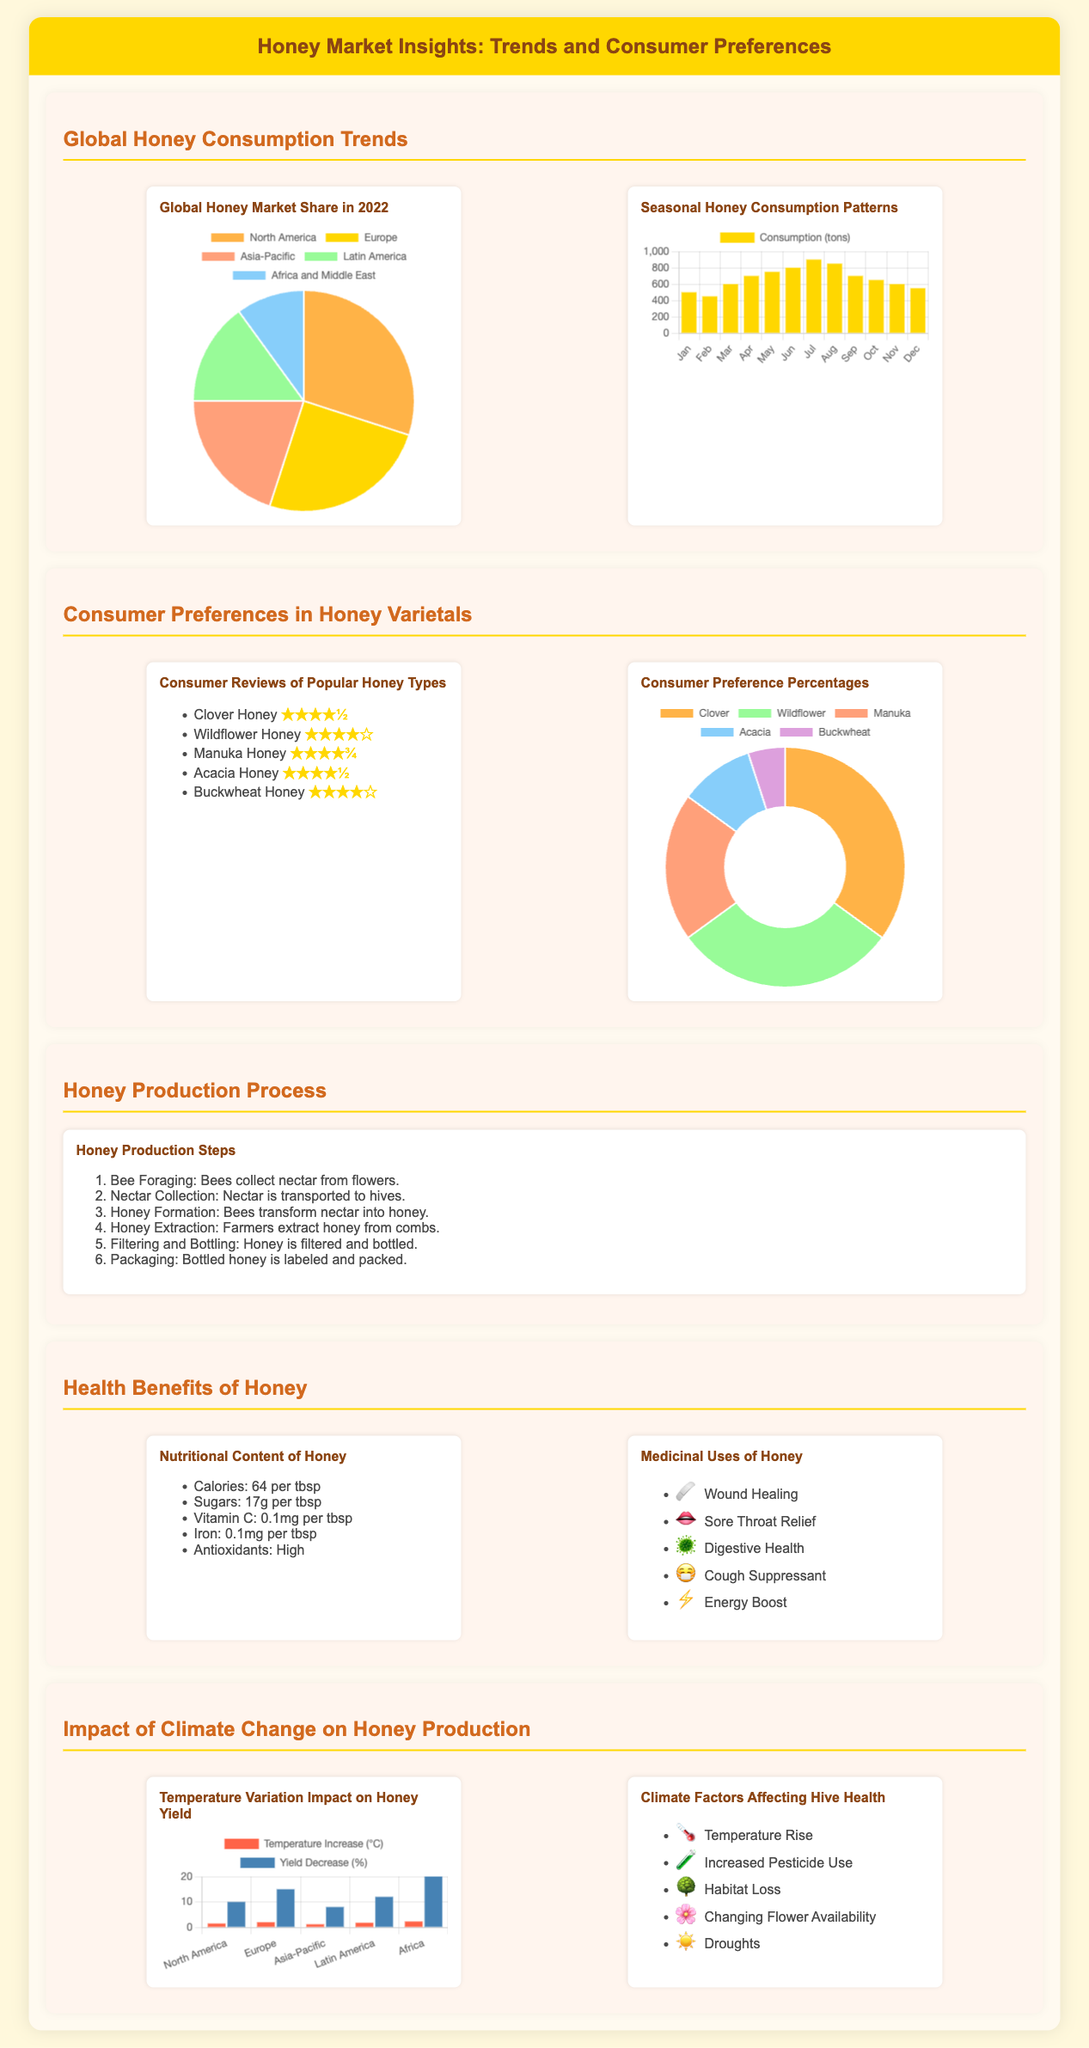What is the largest honey market share in 2022? The market share for North America is the largest in 2022, according to the pie chart.
Answer: North America What percentage of consumers prefer Clover honey? Clover honey constitutes 35% of consumer preferences as shown in the preference chart.
Answer: 35% What is the primary seasonal peak month for honey consumption? The bar chart indicates that honey consumption peaks in July with the highest consumption volume.
Answer: July How many steps are involved in the honey production process? The document lists six distinct steps involved in honey production.
Answer: Six What health benefit of honey is related to sore throat relief? The infographic indicates that honey provides sore throat relief among its medicinal uses.
Answer: Sore throat relief What is the average temperature increase in Africa affecting honey production? The bar chart shows a 2.3°C average temperature increase for Africa, impacting honey yield.
Answer: 2.3°C What type of icon is used for each health benefit listed? Each health benefit is prefaced by a relevant emoji as an icon.
Answer: Emoji What is the lowest star rating for the popular honey types? The lowest star rating shown for buckwheat honey is four stars according to consumer reviews.
Answer: Four stars 